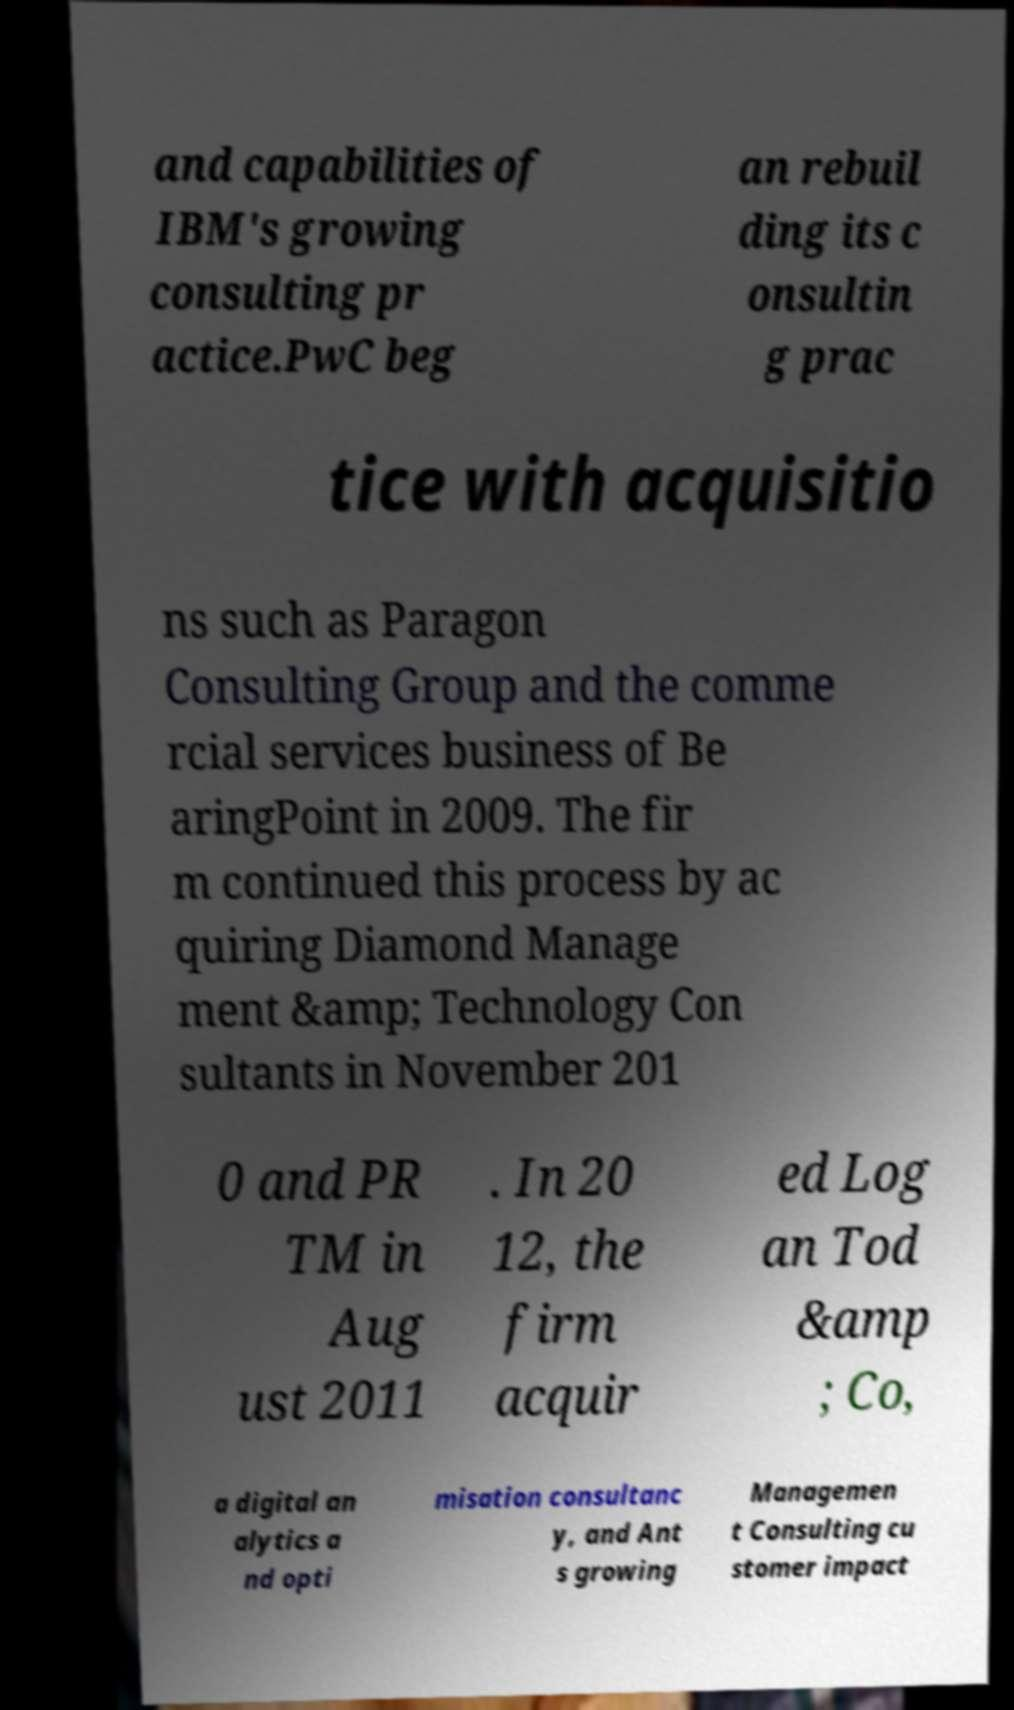Can you accurately transcribe the text from the provided image for me? and capabilities of IBM's growing consulting pr actice.PwC beg an rebuil ding its c onsultin g prac tice with acquisitio ns such as Paragon Consulting Group and the comme rcial services business of Be aringPoint in 2009. The fir m continued this process by ac quiring Diamond Manage ment &amp; Technology Con sultants in November 201 0 and PR TM in Aug ust 2011 . In 20 12, the firm acquir ed Log an Tod &amp ; Co, a digital an alytics a nd opti misation consultanc y, and Ant s growing Managemen t Consulting cu stomer impact 